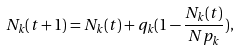<formula> <loc_0><loc_0><loc_500><loc_500>N _ { k } ( t + 1 ) = N _ { k } ( t ) + q _ { k } ( 1 - \frac { N _ { k } ( t ) } { N p _ { k } } ) ,</formula> 